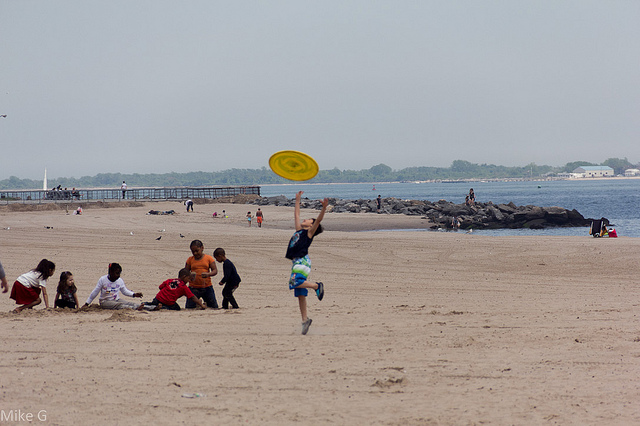<image>What type of pattern is the boy's jacket? I don't know the type of pattern on the boy's jacket. It seems it could be solid, stripe or no jacket. What type of pattern is the boy's jacket? I don't know what type of pattern is the boy's jacket. It is not clear from the given options. 